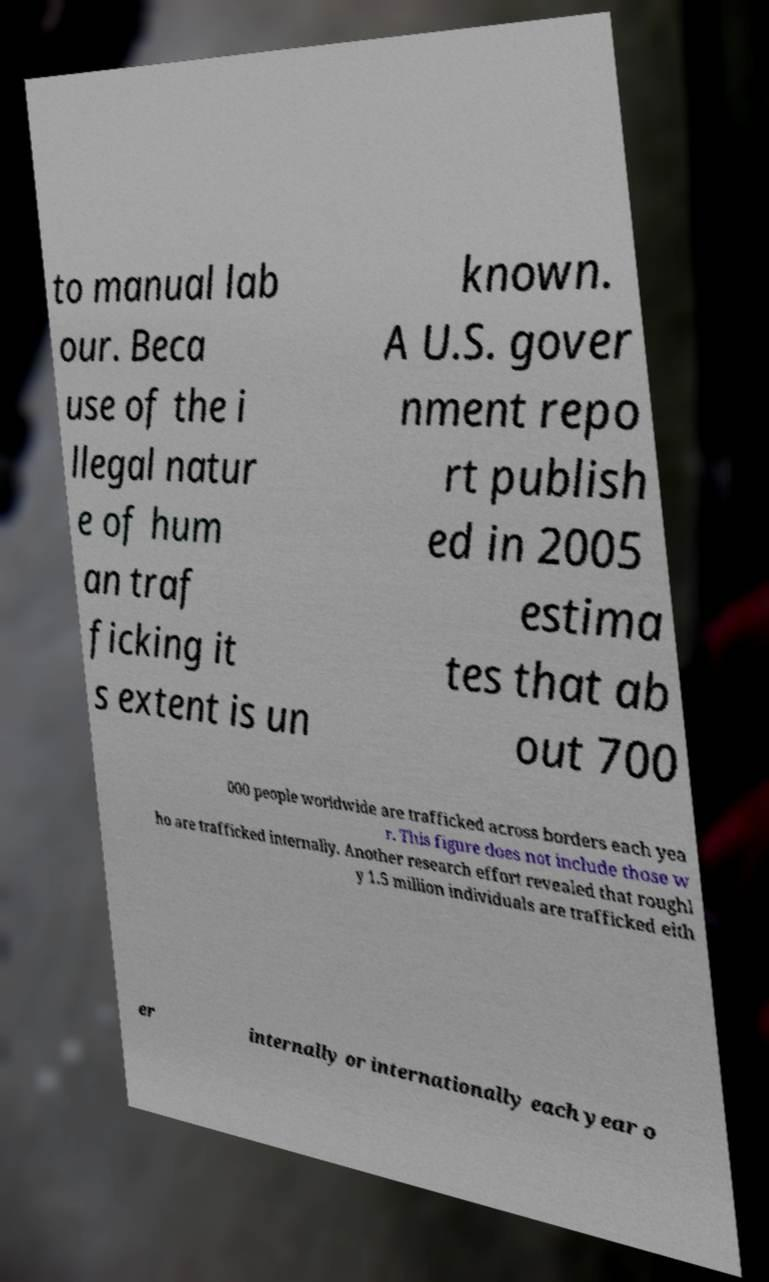For documentation purposes, I need the text within this image transcribed. Could you provide that? to manual lab our. Beca use of the i llegal natur e of hum an traf ficking it s extent is un known. A U.S. gover nment repo rt publish ed in 2005 estima tes that ab out 700 000 people worldwide are trafficked across borders each yea r. This figure does not include those w ho are trafficked internally. Another research effort revealed that roughl y 1.5 million individuals are trafficked eith er internally or internationally each year o 